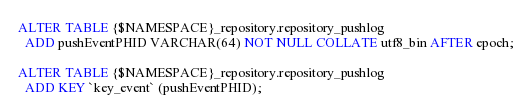<code> <loc_0><loc_0><loc_500><loc_500><_SQL_>ALTER TABLE {$NAMESPACE}_repository.repository_pushlog
  ADD pushEventPHID VARCHAR(64) NOT NULL COLLATE utf8_bin AFTER epoch;

ALTER TABLE {$NAMESPACE}_repository.repository_pushlog
  ADD KEY `key_event` (pushEventPHID);
</code> 